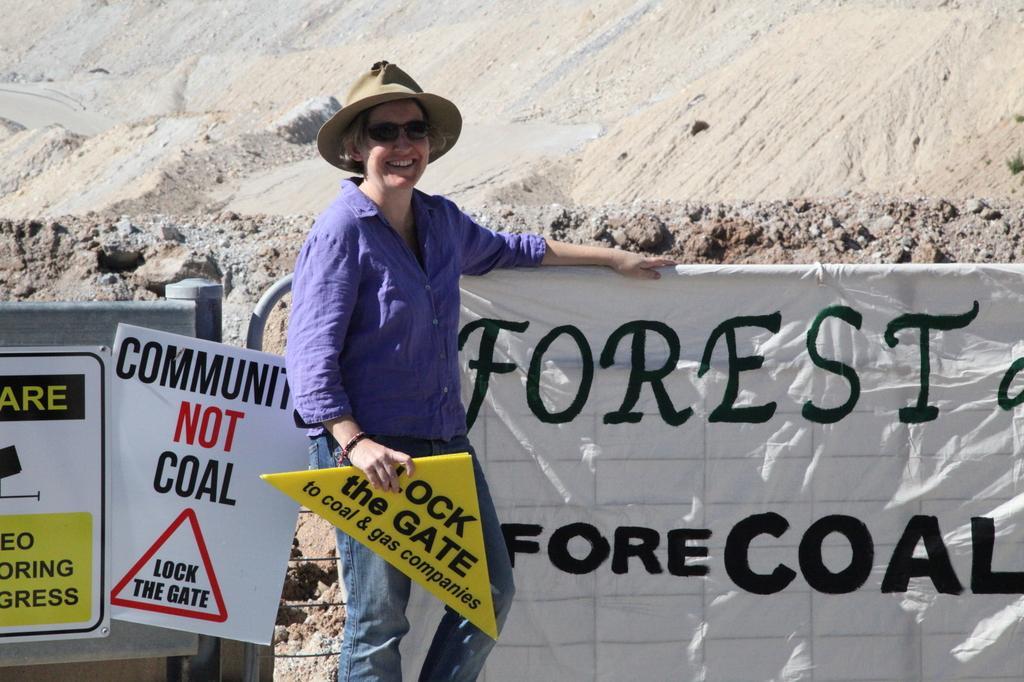How would you summarize this image in a sentence or two? In this image I can see a person standing and smiling. She is wearing a hat and goggles. She is holding a yellow board. There is a banner and there are mountains at the back. 